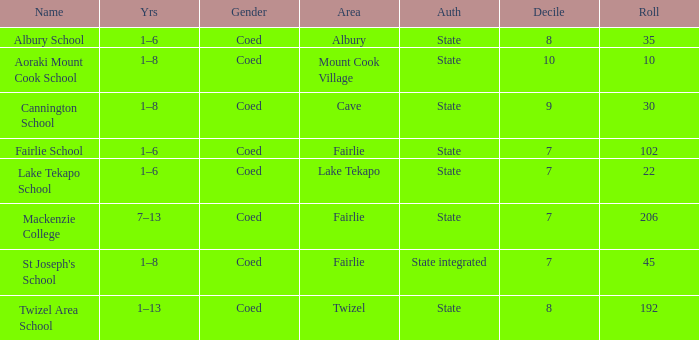What is the total Decile that has a state authority, fairlie area and roll smarter than 206? 1.0. Write the full table. {'header': ['Name', 'Yrs', 'Gender', 'Area', 'Auth', 'Decile', 'Roll'], 'rows': [['Albury School', '1–6', 'Coed', 'Albury', 'State', '8', '35'], ['Aoraki Mount Cook School', '1–8', 'Coed', 'Mount Cook Village', 'State', '10', '10'], ['Cannington School', '1–8', 'Coed', 'Cave', 'State', '9', '30'], ['Fairlie School', '1–6', 'Coed', 'Fairlie', 'State', '7', '102'], ['Lake Tekapo School', '1–6', 'Coed', 'Lake Tekapo', 'State', '7', '22'], ['Mackenzie College', '7–13', 'Coed', 'Fairlie', 'State', '7', '206'], ["St Joseph's School", '1–8', 'Coed', 'Fairlie', 'State integrated', '7', '45'], ['Twizel Area School', '1–13', 'Coed', 'Twizel', 'State', '8', '192']]} 